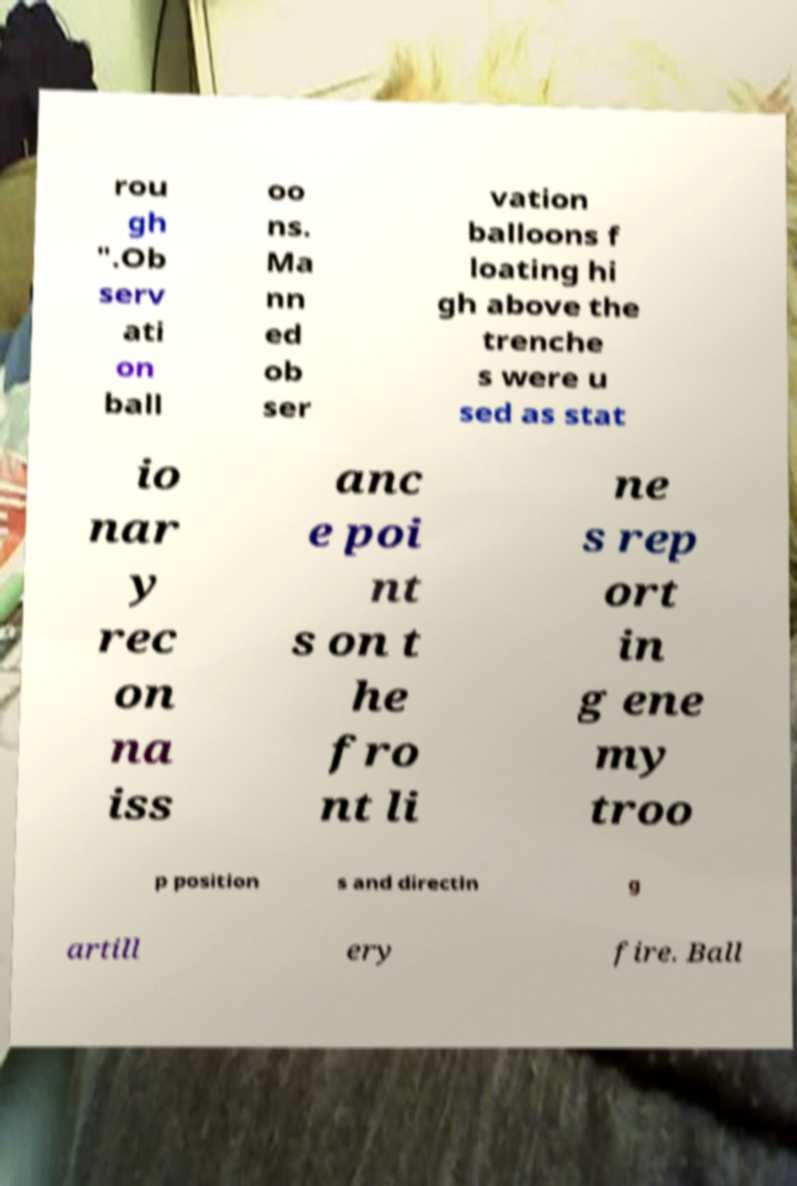For documentation purposes, I need the text within this image transcribed. Could you provide that? rou gh ".Ob serv ati on ball oo ns. Ma nn ed ob ser vation balloons f loating hi gh above the trenche s were u sed as stat io nar y rec on na iss anc e poi nt s on t he fro nt li ne s rep ort in g ene my troo p position s and directin g artill ery fire. Ball 